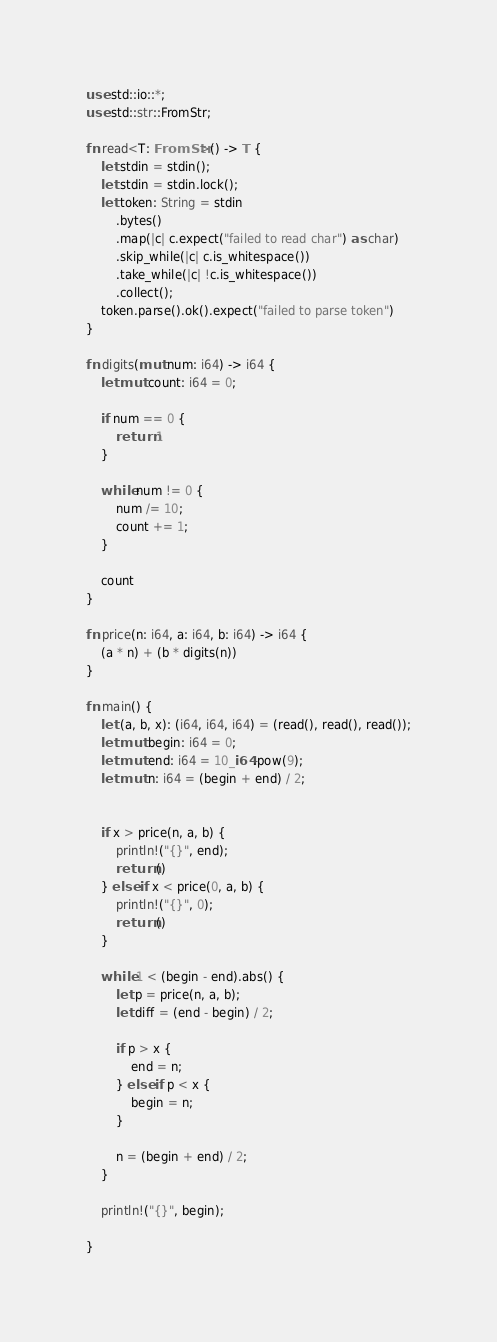<code> <loc_0><loc_0><loc_500><loc_500><_Rust_>use std::io::*;
use std::str::FromStr;

fn read<T: FromStr>() -> T {
    let stdin = stdin();
    let stdin = stdin.lock();
    let token: String = stdin
        .bytes()
        .map(|c| c.expect("failed to read char") as char) 
        .skip_while(|c| c.is_whitespace())
        .take_while(|c| !c.is_whitespace())
        .collect();
    token.parse().ok().expect("failed to parse token")
}

fn digits(mut num: i64) -> i64 {
    let mut count: i64 = 0;

    if num == 0 {
        return 1
    }
    
    while num != 0 {
        num /= 10;
        count += 1;
    }

    count
}

fn price(n: i64, a: i64, b: i64) -> i64 {
    (a * n) + (b * digits(n))
}

fn main() {
    let (a, b, x): (i64, i64, i64) = (read(), read(), read());
    let mut begin: i64 = 0;
    let mut end: i64 = 10_i64.pow(9);
    let mut n: i64 = (begin + end) / 2;


    if x > price(n, a, b) {
        println!("{}", end);
        return ()
    } else if x < price(0, a, b) {
        println!("{}", 0);
        return ()
    }
    
    while 1 < (begin - end).abs() {
        let p = price(n, a, b);
        let diff = (end - begin) / 2;

        if p > x {
            end = n;
        } else if p < x {
            begin = n;
        }
        
        n = (begin + end) / 2;
    }

    println!("{}", begin);
    
}
</code> 